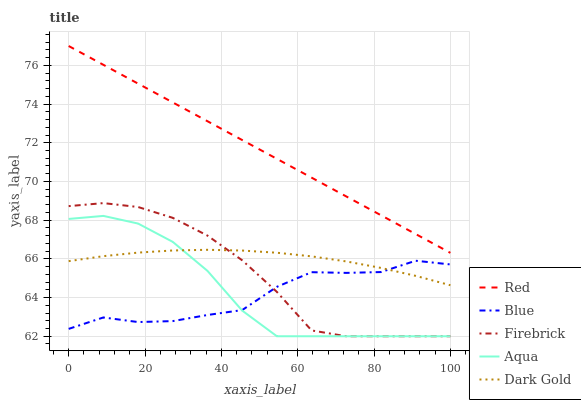Does Blue have the minimum area under the curve?
Answer yes or no. Yes. Does Red have the maximum area under the curve?
Answer yes or no. Yes. Does Firebrick have the minimum area under the curve?
Answer yes or no. No. Does Firebrick have the maximum area under the curve?
Answer yes or no. No. Is Red the smoothest?
Answer yes or no. Yes. Is Blue the roughest?
Answer yes or no. Yes. Is Firebrick the smoothest?
Answer yes or no. No. Is Firebrick the roughest?
Answer yes or no. No. Does Firebrick have the lowest value?
Answer yes or no. Yes. Does Red have the lowest value?
Answer yes or no. No. Does Red have the highest value?
Answer yes or no. Yes. Does Firebrick have the highest value?
Answer yes or no. No. Is Blue less than Red?
Answer yes or no. Yes. Is Red greater than Firebrick?
Answer yes or no. Yes. Does Firebrick intersect Aqua?
Answer yes or no. Yes. Is Firebrick less than Aqua?
Answer yes or no. No. Is Firebrick greater than Aqua?
Answer yes or no. No. Does Blue intersect Red?
Answer yes or no. No. 